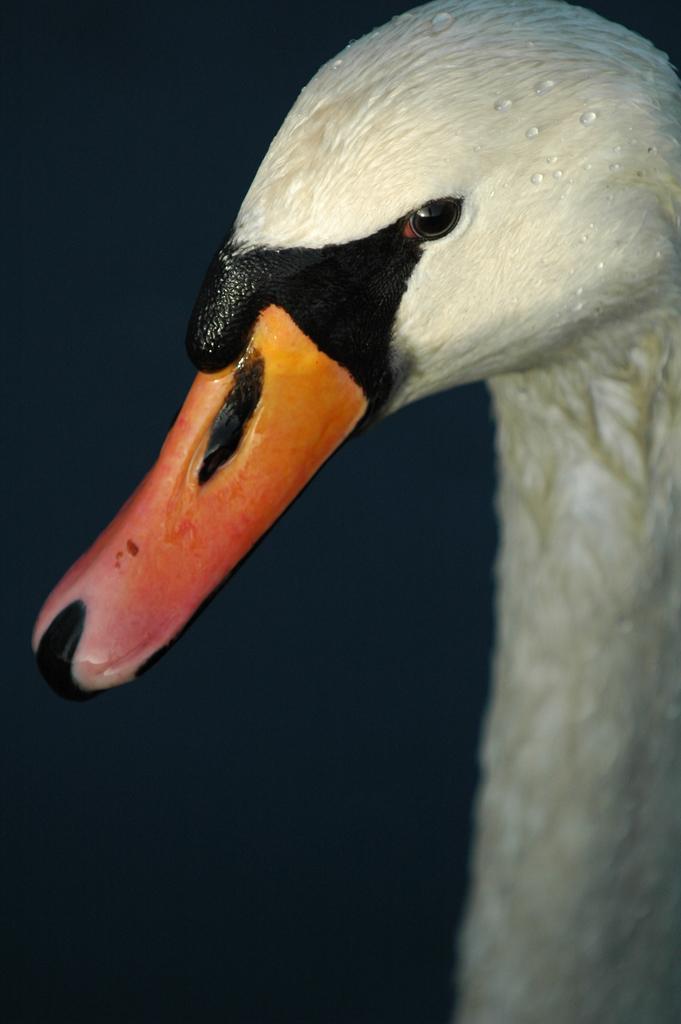Please provide a concise description of this image. In this image I can see the bird which is in cream, black, orange and red color. I can see there is a black background. 